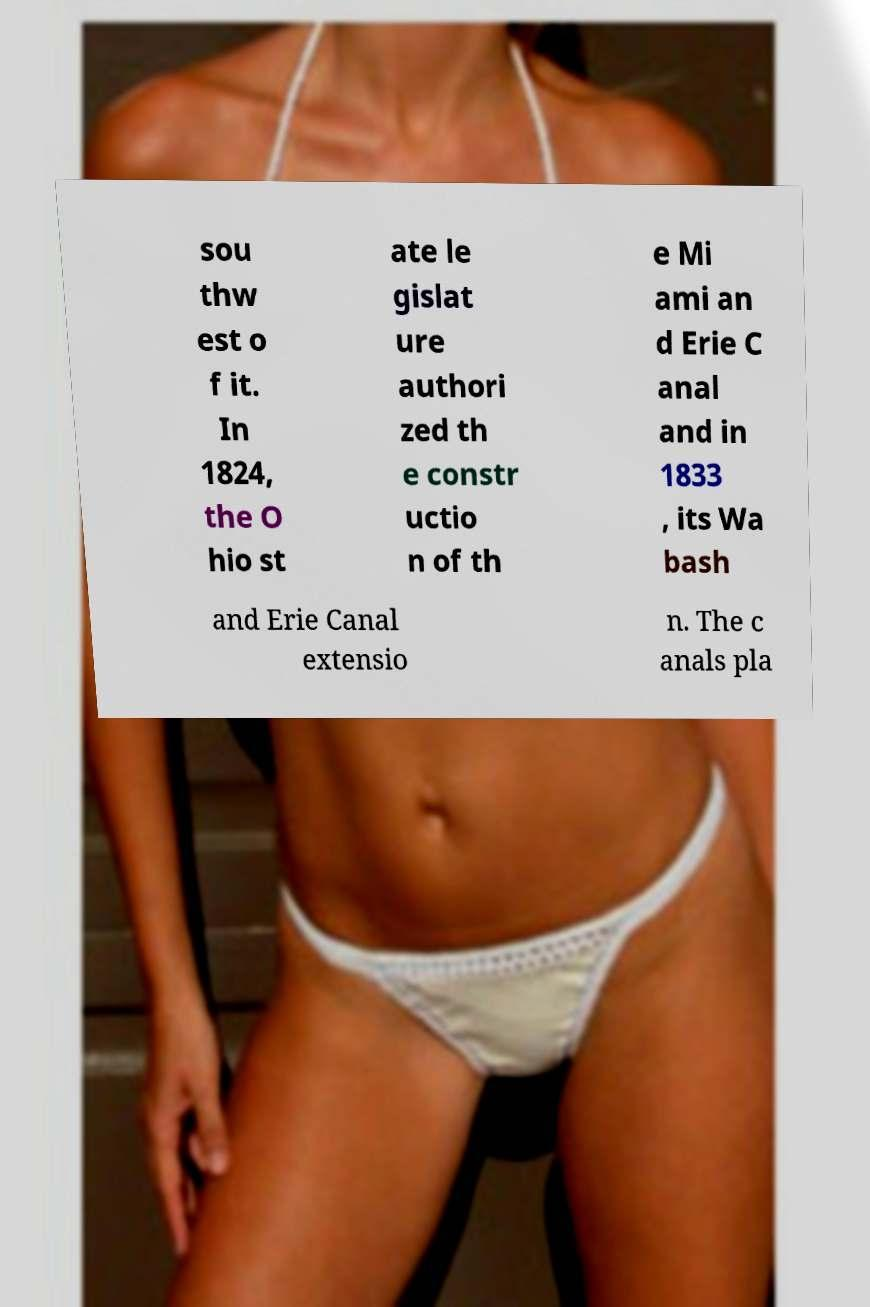Could you extract and type out the text from this image? sou thw est o f it. In 1824, the O hio st ate le gislat ure authori zed th e constr uctio n of th e Mi ami an d Erie C anal and in 1833 , its Wa bash and Erie Canal extensio n. The c anals pla 